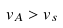Convert formula to latex. <formula><loc_0><loc_0><loc_500><loc_500>v _ { A } > v _ { s }</formula> 